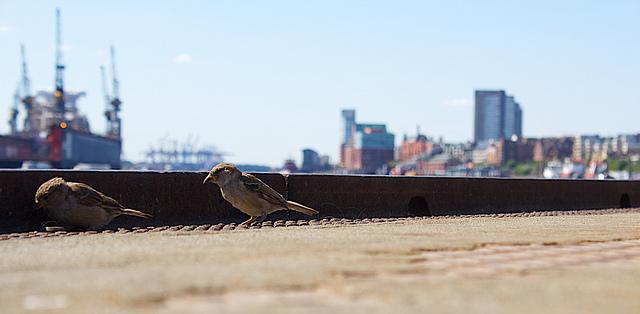Are they by the docks?
Be succinct. Yes. How many birds are in the picture?
Write a very short answer. 2. Is one of the birds sitting on its butt?
Write a very short answer. No. 